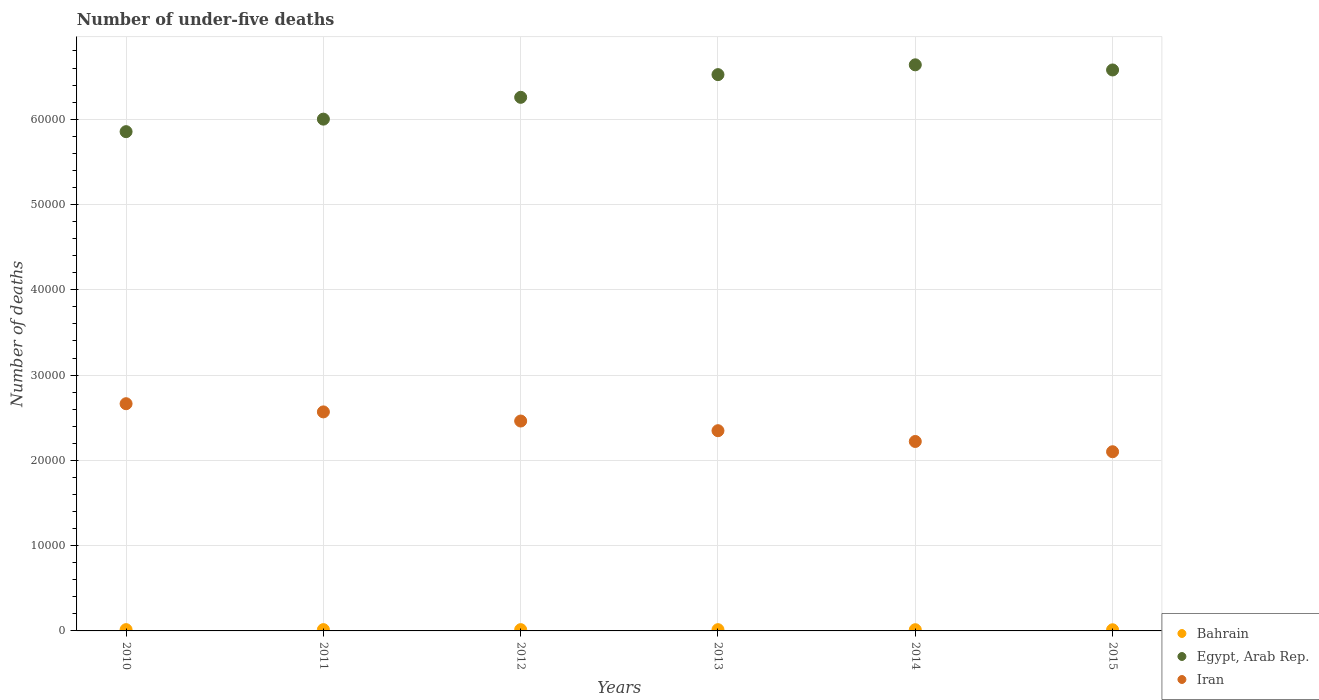How many different coloured dotlines are there?
Your answer should be compact. 3. What is the number of under-five deaths in Egypt, Arab Rep. in 2014?
Your answer should be very brief. 6.64e+04. Across all years, what is the maximum number of under-five deaths in Iran?
Keep it short and to the point. 2.66e+04. Across all years, what is the minimum number of under-five deaths in Bahrain?
Provide a short and direct response. 135. In which year was the number of under-five deaths in Bahrain maximum?
Your answer should be very brief. 2011. What is the total number of under-five deaths in Bahrain in the graph?
Provide a succinct answer. 878. What is the difference between the number of under-five deaths in Iran in 2010 and that in 2012?
Make the answer very short. 2030. What is the difference between the number of under-five deaths in Bahrain in 2011 and the number of under-five deaths in Egypt, Arab Rep. in 2014?
Make the answer very short. -6.62e+04. What is the average number of under-five deaths in Egypt, Arab Rep. per year?
Offer a very short reply. 6.31e+04. In the year 2014, what is the difference between the number of under-five deaths in Iran and number of under-five deaths in Egypt, Arab Rep.?
Provide a succinct answer. -4.42e+04. What is the ratio of the number of under-five deaths in Egypt, Arab Rep. in 2014 to that in 2015?
Provide a short and direct response. 1.01. Is the number of under-five deaths in Iran in 2010 less than that in 2011?
Provide a succinct answer. No. What is the difference between the highest and the lowest number of under-five deaths in Egypt, Arab Rep.?
Keep it short and to the point. 7837. How many years are there in the graph?
Provide a succinct answer. 6. What is the difference between two consecutive major ticks on the Y-axis?
Ensure brevity in your answer.  10000. Does the graph contain any zero values?
Keep it short and to the point. No. Does the graph contain grids?
Your answer should be compact. Yes. Where does the legend appear in the graph?
Offer a very short reply. Bottom right. How many legend labels are there?
Your response must be concise. 3. How are the legend labels stacked?
Provide a succinct answer. Vertical. What is the title of the graph?
Ensure brevity in your answer.  Number of under-five deaths. What is the label or title of the Y-axis?
Offer a very short reply. Number of deaths. What is the Number of deaths of Bahrain in 2010?
Your answer should be very brief. 151. What is the Number of deaths of Egypt, Arab Rep. in 2010?
Provide a succinct answer. 5.85e+04. What is the Number of deaths of Iran in 2010?
Your response must be concise. 2.66e+04. What is the Number of deaths in Bahrain in 2011?
Your answer should be compact. 152. What is the Number of deaths in Egypt, Arab Rep. in 2011?
Give a very brief answer. 6.00e+04. What is the Number of deaths in Iran in 2011?
Keep it short and to the point. 2.57e+04. What is the Number of deaths of Bahrain in 2012?
Provide a succinct answer. 150. What is the Number of deaths of Egypt, Arab Rep. in 2012?
Your response must be concise. 6.26e+04. What is the Number of deaths of Iran in 2012?
Offer a very short reply. 2.46e+04. What is the Number of deaths in Bahrain in 2013?
Give a very brief answer. 148. What is the Number of deaths of Egypt, Arab Rep. in 2013?
Your response must be concise. 6.52e+04. What is the Number of deaths of Iran in 2013?
Provide a succinct answer. 2.35e+04. What is the Number of deaths in Bahrain in 2014?
Give a very brief answer. 142. What is the Number of deaths of Egypt, Arab Rep. in 2014?
Keep it short and to the point. 6.64e+04. What is the Number of deaths in Iran in 2014?
Keep it short and to the point. 2.22e+04. What is the Number of deaths of Bahrain in 2015?
Keep it short and to the point. 135. What is the Number of deaths in Egypt, Arab Rep. in 2015?
Give a very brief answer. 6.58e+04. What is the Number of deaths in Iran in 2015?
Keep it short and to the point. 2.10e+04. Across all years, what is the maximum Number of deaths in Bahrain?
Make the answer very short. 152. Across all years, what is the maximum Number of deaths in Egypt, Arab Rep.?
Your answer should be very brief. 6.64e+04. Across all years, what is the maximum Number of deaths in Iran?
Your response must be concise. 2.66e+04. Across all years, what is the minimum Number of deaths in Bahrain?
Offer a terse response. 135. Across all years, what is the minimum Number of deaths of Egypt, Arab Rep.?
Make the answer very short. 5.85e+04. Across all years, what is the minimum Number of deaths in Iran?
Make the answer very short. 2.10e+04. What is the total Number of deaths of Bahrain in the graph?
Provide a short and direct response. 878. What is the total Number of deaths of Egypt, Arab Rep. in the graph?
Provide a succinct answer. 3.78e+05. What is the total Number of deaths in Iran in the graph?
Your response must be concise. 1.44e+05. What is the difference between the Number of deaths of Egypt, Arab Rep. in 2010 and that in 2011?
Provide a succinct answer. -1468. What is the difference between the Number of deaths in Iran in 2010 and that in 2011?
Provide a succinct answer. 960. What is the difference between the Number of deaths in Bahrain in 2010 and that in 2012?
Offer a terse response. 1. What is the difference between the Number of deaths in Egypt, Arab Rep. in 2010 and that in 2012?
Give a very brief answer. -4026. What is the difference between the Number of deaths of Iran in 2010 and that in 2012?
Keep it short and to the point. 2030. What is the difference between the Number of deaths in Egypt, Arab Rep. in 2010 and that in 2013?
Provide a succinct answer. -6687. What is the difference between the Number of deaths in Iran in 2010 and that in 2013?
Make the answer very short. 3164. What is the difference between the Number of deaths of Egypt, Arab Rep. in 2010 and that in 2014?
Provide a short and direct response. -7837. What is the difference between the Number of deaths in Iran in 2010 and that in 2014?
Your answer should be very brief. 4427. What is the difference between the Number of deaths in Egypt, Arab Rep. in 2010 and that in 2015?
Your answer should be compact. -7234. What is the difference between the Number of deaths of Iran in 2010 and that in 2015?
Give a very brief answer. 5631. What is the difference between the Number of deaths in Bahrain in 2011 and that in 2012?
Offer a terse response. 2. What is the difference between the Number of deaths in Egypt, Arab Rep. in 2011 and that in 2012?
Give a very brief answer. -2558. What is the difference between the Number of deaths in Iran in 2011 and that in 2012?
Your answer should be compact. 1070. What is the difference between the Number of deaths of Egypt, Arab Rep. in 2011 and that in 2013?
Your answer should be very brief. -5219. What is the difference between the Number of deaths of Iran in 2011 and that in 2013?
Make the answer very short. 2204. What is the difference between the Number of deaths in Bahrain in 2011 and that in 2014?
Ensure brevity in your answer.  10. What is the difference between the Number of deaths in Egypt, Arab Rep. in 2011 and that in 2014?
Your response must be concise. -6369. What is the difference between the Number of deaths of Iran in 2011 and that in 2014?
Your answer should be very brief. 3467. What is the difference between the Number of deaths of Bahrain in 2011 and that in 2015?
Offer a very short reply. 17. What is the difference between the Number of deaths in Egypt, Arab Rep. in 2011 and that in 2015?
Your answer should be compact. -5766. What is the difference between the Number of deaths in Iran in 2011 and that in 2015?
Offer a very short reply. 4671. What is the difference between the Number of deaths of Egypt, Arab Rep. in 2012 and that in 2013?
Provide a succinct answer. -2661. What is the difference between the Number of deaths of Iran in 2012 and that in 2013?
Your response must be concise. 1134. What is the difference between the Number of deaths in Egypt, Arab Rep. in 2012 and that in 2014?
Ensure brevity in your answer.  -3811. What is the difference between the Number of deaths in Iran in 2012 and that in 2014?
Make the answer very short. 2397. What is the difference between the Number of deaths in Bahrain in 2012 and that in 2015?
Provide a short and direct response. 15. What is the difference between the Number of deaths in Egypt, Arab Rep. in 2012 and that in 2015?
Keep it short and to the point. -3208. What is the difference between the Number of deaths of Iran in 2012 and that in 2015?
Keep it short and to the point. 3601. What is the difference between the Number of deaths of Bahrain in 2013 and that in 2014?
Make the answer very short. 6. What is the difference between the Number of deaths in Egypt, Arab Rep. in 2013 and that in 2014?
Provide a short and direct response. -1150. What is the difference between the Number of deaths of Iran in 2013 and that in 2014?
Provide a succinct answer. 1263. What is the difference between the Number of deaths of Bahrain in 2013 and that in 2015?
Keep it short and to the point. 13. What is the difference between the Number of deaths of Egypt, Arab Rep. in 2013 and that in 2015?
Offer a terse response. -547. What is the difference between the Number of deaths in Iran in 2013 and that in 2015?
Provide a short and direct response. 2467. What is the difference between the Number of deaths in Bahrain in 2014 and that in 2015?
Offer a very short reply. 7. What is the difference between the Number of deaths in Egypt, Arab Rep. in 2014 and that in 2015?
Offer a very short reply. 603. What is the difference between the Number of deaths of Iran in 2014 and that in 2015?
Your response must be concise. 1204. What is the difference between the Number of deaths of Bahrain in 2010 and the Number of deaths of Egypt, Arab Rep. in 2011?
Your answer should be compact. -5.99e+04. What is the difference between the Number of deaths in Bahrain in 2010 and the Number of deaths in Iran in 2011?
Offer a terse response. -2.55e+04. What is the difference between the Number of deaths in Egypt, Arab Rep. in 2010 and the Number of deaths in Iran in 2011?
Keep it short and to the point. 3.29e+04. What is the difference between the Number of deaths of Bahrain in 2010 and the Number of deaths of Egypt, Arab Rep. in 2012?
Ensure brevity in your answer.  -6.24e+04. What is the difference between the Number of deaths of Bahrain in 2010 and the Number of deaths of Iran in 2012?
Ensure brevity in your answer.  -2.45e+04. What is the difference between the Number of deaths of Egypt, Arab Rep. in 2010 and the Number of deaths of Iran in 2012?
Ensure brevity in your answer.  3.39e+04. What is the difference between the Number of deaths in Bahrain in 2010 and the Number of deaths in Egypt, Arab Rep. in 2013?
Ensure brevity in your answer.  -6.51e+04. What is the difference between the Number of deaths of Bahrain in 2010 and the Number of deaths of Iran in 2013?
Your response must be concise. -2.33e+04. What is the difference between the Number of deaths in Egypt, Arab Rep. in 2010 and the Number of deaths in Iran in 2013?
Keep it short and to the point. 3.51e+04. What is the difference between the Number of deaths of Bahrain in 2010 and the Number of deaths of Egypt, Arab Rep. in 2014?
Ensure brevity in your answer.  -6.62e+04. What is the difference between the Number of deaths in Bahrain in 2010 and the Number of deaths in Iran in 2014?
Ensure brevity in your answer.  -2.21e+04. What is the difference between the Number of deaths of Egypt, Arab Rep. in 2010 and the Number of deaths of Iran in 2014?
Provide a succinct answer. 3.63e+04. What is the difference between the Number of deaths in Bahrain in 2010 and the Number of deaths in Egypt, Arab Rep. in 2015?
Give a very brief answer. -6.56e+04. What is the difference between the Number of deaths of Bahrain in 2010 and the Number of deaths of Iran in 2015?
Provide a succinct answer. -2.09e+04. What is the difference between the Number of deaths in Egypt, Arab Rep. in 2010 and the Number of deaths in Iran in 2015?
Your answer should be very brief. 3.75e+04. What is the difference between the Number of deaths of Bahrain in 2011 and the Number of deaths of Egypt, Arab Rep. in 2012?
Provide a succinct answer. -6.24e+04. What is the difference between the Number of deaths of Bahrain in 2011 and the Number of deaths of Iran in 2012?
Your answer should be very brief. -2.45e+04. What is the difference between the Number of deaths of Egypt, Arab Rep. in 2011 and the Number of deaths of Iran in 2012?
Keep it short and to the point. 3.54e+04. What is the difference between the Number of deaths of Bahrain in 2011 and the Number of deaths of Egypt, Arab Rep. in 2013?
Provide a short and direct response. -6.51e+04. What is the difference between the Number of deaths of Bahrain in 2011 and the Number of deaths of Iran in 2013?
Give a very brief answer. -2.33e+04. What is the difference between the Number of deaths in Egypt, Arab Rep. in 2011 and the Number of deaths in Iran in 2013?
Offer a terse response. 3.65e+04. What is the difference between the Number of deaths in Bahrain in 2011 and the Number of deaths in Egypt, Arab Rep. in 2014?
Make the answer very short. -6.62e+04. What is the difference between the Number of deaths in Bahrain in 2011 and the Number of deaths in Iran in 2014?
Give a very brief answer. -2.21e+04. What is the difference between the Number of deaths of Egypt, Arab Rep. in 2011 and the Number of deaths of Iran in 2014?
Offer a terse response. 3.78e+04. What is the difference between the Number of deaths of Bahrain in 2011 and the Number of deaths of Egypt, Arab Rep. in 2015?
Provide a succinct answer. -6.56e+04. What is the difference between the Number of deaths in Bahrain in 2011 and the Number of deaths in Iran in 2015?
Keep it short and to the point. -2.09e+04. What is the difference between the Number of deaths in Egypt, Arab Rep. in 2011 and the Number of deaths in Iran in 2015?
Make the answer very short. 3.90e+04. What is the difference between the Number of deaths of Bahrain in 2012 and the Number of deaths of Egypt, Arab Rep. in 2013?
Your response must be concise. -6.51e+04. What is the difference between the Number of deaths of Bahrain in 2012 and the Number of deaths of Iran in 2013?
Provide a short and direct response. -2.33e+04. What is the difference between the Number of deaths of Egypt, Arab Rep. in 2012 and the Number of deaths of Iran in 2013?
Offer a very short reply. 3.91e+04. What is the difference between the Number of deaths of Bahrain in 2012 and the Number of deaths of Egypt, Arab Rep. in 2014?
Provide a short and direct response. -6.62e+04. What is the difference between the Number of deaths in Bahrain in 2012 and the Number of deaths in Iran in 2014?
Provide a succinct answer. -2.21e+04. What is the difference between the Number of deaths in Egypt, Arab Rep. in 2012 and the Number of deaths in Iran in 2014?
Your answer should be compact. 4.04e+04. What is the difference between the Number of deaths in Bahrain in 2012 and the Number of deaths in Egypt, Arab Rep. in 2015?
Offer a terse response. -6.56e+04. What is the difference between the Number of deaths in Bahrain in 2012 and the Number of deaths in Iran in 2015?
Provide a short and direct response. -2.09e+04. What is the difference between the Number of deaths in Egypt, Arab Rep. in 2012 and the Number of deaths in Iran in 2015?
Make the answer very short. 4.16e+04. What is the difference between the Number of deaths of Bahrain in 2013 and the Number of deaths of Egypt, Arab Rep. in 2014?
Provide a succinct answer. -6.62e+04. What is the difference between the Number of deaths in Bahrain in 2013 and the Number of deaths in Iran in 2014?
Provide a succinct answer. -2.21e+04. What is the difference between the Number of deaths in Egypt, Arab Rep. in 2013 and the Number of deaths in Iran in 2014?
Your response must be concise. 4.30e+04. What is the difference between the Number of deaths in Bahrain in 2013 and the Number of deaths in Egypt, Arab Rep. in 2015?
Your answer should be compact. -6.56e+04. What is the difference between the Number of deaths in Bahrain in 2013 and the Number of deaths in Iran in 2015?
Keep it short and to the point. -2.09e+04. What is the difference between the Number of deaths of Egypt, Arab Rep. in 2013 and the Number of deaths of Iran in 2015?
Offer a very short reply. 4.42e+04. What is the difference between the Number of deaths in Bahrain in 2014 and the Number of deaths in Egypt, Arab Rep. in 2015?
Provide a succinct answer. -6.56e+04. What is the difference between the Number of deaths of Bahrain in 2014 and the Number of deaths of Iran in 2015?
Ensure brevity in your answer.  -2.09e+04. What is the difference between the Number of deaths in Egypt, Arab Rep. in 2014 and the Number of deaths in Iran in 2015?
Your answer should be compact. 4.54e+04. What is the average Number of deaths of Bahrain per year?
Your answer should be very brief. 146.33. What is the average Number of deaths of Egypt, Arab Rep. per year?
Keep it short and to the point. 6.31e+04. What is the average Number of deaths in Iran per year?
Your response must be concise. 2.39e+04. In the year 2010, what is the difference between the Number of deaths of Bahrain and Number of deaths of Egypt, Arab Rep.?
Offer a terse response. -5.84e+04. In the year 2010, what is the difference between the Number of deaths of Bahrain and Number of deaths of Iran?
Your answer should be very brief. -2.65e+04. In the year 2010, what is the difference between the Number of deaths in Egypt, Arab Rep. and Number of deaths in Iran?
Your answer should be compact. 3.19e+04. In the year 2011, what is the difference between the Number of deaths in Bahrain and Number of deaths in Egypt, Arab Rep.?
Your response must be concise. -5.99e+04. In the year 2011, what is the difference between the Number of deaths of Bahrain and Number of deaths of Iran?
Offer a very short reply. -2.55e+04. In the year 2011, what is the difference between the Number of deaths in Egypt, Arab Rep. and Number of deaths in Iran?
Keep it short and to the point. 3.43e+04. In the year 2012, what is the difference between the Number of deaths in Bahrain and Number of deaths in Egypt, Arab Rep.?
Provide a short and direct response. -6.24e+04. In the year 2012, what is the difference between the Number of deaths in Bahrain and Number of deaths in Iran?
Keep it short and to the point. -2.45e+04. In the year 2012, what is the difference between the Number of deaths in Egypt, Arab Rep. and Number of deaths in Iran?
Your answer should be very brief. 3.80e+04. In the year 2013, what is the difference between the Number of deaths in Bahrain and Number of deaths in Egypt, Arab Rep.?
Your response must be concise. -6.51e+04. In the year 2013, what is the difference between the Number of deaths in Bahrain and Number of deaths in Iran?
Offer a terse response. -2.33e+04. In the year 2013, what is the difference between the Number of deaths of Egypt, Arab Rep. and Number of deaths of Iran?
Give a very brief answer. 4.18e+04. In the year 2014, what is the difference between the Number of deaths in Bahrain and Number of deaths in Egypt, Arab Rep.?
Your answer should be very brief. -6.62e+04. In the year 2014, what is the difference between the Number of deaths of Bahrain and Number of deaths of Iran?
Make the answer very short. -2.21e+04. In the year 2014, what is the difference between the Number of deaths of Egypt, Arab Rep. and Number of deaths of Iran?
Provide a succinct answer. 4.42e+04. In the year 2015, what is the difference between the Number of deaths of Bahrain and Number of deaths of Egypt, Arab Rep.?
Offer a very short reply. -6.56e+04. In the year 2015, what is the difference between the Number of deaths in Bahrain and Number of deaths in Iran?
Ensure brevity in your answer.  -2.09e+04. In the year 2015, what is the difference between the Number of deaths in Egypt, Arab Rep. and Number of deaths in Iran?
Give a very brief answer. 4.48e+04. What is the ratio of the Number of deaths of Bahrain in 2010 to that in 2011?
Offer a terse response. 0.99. What is the ratio of the Number of deaths of Egypt, Arab Rep. in 2010 to that in 2011?
Provide a short and direct response. 0.98. What is the ratio of the Number of deaths of Iran in 2010 to that in 2011?
Ensure brevity in your answer.  1.04. What is the ratio of the Number of deaths of Bahrain in 2010 to that in 2012?
Give a very brief answer. 1.01. What is the ratio of the Number of deaths in Egypt, Arab Rep. in 2010 to that in 2012?
Make the answer very short. 0.94. What is the ratio of the Number of deaths in Iran in 2010 to that in 2012?
Provide a short and direct response. 1.08. What is the ratio of the Number of deaths in Bahrain in 2010 to that in 2013?
Provide a short and direct response. 1.02. What is the ratio of the Number of deaths in Egypt, Arab Rep. in 2010 to that in 2013?
Your answer should be compact. 0.9. What is the ratio of the Number of deaths in Iran in 2010 to that in 2013?
Offer a terse response. 1.13. What is the ratio of the Number of deaths in Bahrain in 2010 to that in 2014?
Give a very brief answer. 1.06. What is the ratio of the Number of deaths in Egypt, Arab Rep. in 2010 to that in 2014?
Provide a succinct answer. 0.88. What is the ratio of the Number of deaths in Iran in 2010 to that in 2014?
Your answer should be very brief. 1.2. What is the ratio of the Number of deaths of Bahrain in 2010 to that in 2015?
Provide a succinct answer. 1.12. What is the ratio of the Number of deaths of Egypt, Arab Rep. in 2010 to that in 2015?
Ensure brevity in your answer.  0.89. What is the ratio of the Number of deaths of Iran in 2010 to that in 2015?
Provide a short and direct response. 1.27. What is the ratio of the Number of deaths of Bahrain in 2011 to that in 2012?
Offer a terse response. 1.01. What is the ratio of the Number of deaths in Egypt, Arab Rep. in 2011 to that in 2012?
Offer a very short reply. 0.96. What is the ratio of the Number of deaths in Iran in 2011 to that in 2012?
Offer a terse response. 1.04. What is the ratio of the Number of deaths of Bahrain in 2011 to that in 2013?
Ensure brevity in your answer.  1.03. What is the ratio of the Number of deaths of Egypt, Arab Rep. in 2011 to that in 2013?
Keep it short and to the point. 0.92. What is the ratio of the Number of deaths in Iran in 2011 to that in 2013?
Give a very brief answer. 1.09. What is the ratio of the Number of deaths of Bahrain in 2011 to that in 2014?
Offer a very short reply. 1.07. What is the ratio of the Number of deaths of Egypt, Arab Rep. in 2011 to that in 2014?
Your answer should be very brief. 0.9. What is the ratio of the Number of deaths of Iran in 2011 to that in 2014?
Your answer should be very brief. 1.16. What is the ratio of the Number of deaths of Bahrain in 2011 to that in 2015?
Ensure brevity in your answer.  1.13. What is the ratio of the Number of deaths of Egypt, Arab Rep. in 2011 to that in 2015?
Make the answer very short. 0.91. What is the ratio of the Number of deaths of Iran in 2011 to that in 2015?
Provide a succinct answer. 1.22. What is the ratio of the Number of deaths of Bahrain in 2012 to that in 2013?
Offer a very short reply. 1.01. What is the ratio of the Number of deaths in Egypt, Arab Rep. in 2012 to that in 2013?
Your answer should be compact. 0.96. What is the ratio of the Number of deaths in Iran in 2012 to that in 2013?
Your response must be concise. 1.05. What is the ratio of the Number of deaths of Bahrain in 2012 to that in 2014?
Make the answer very short. 1.06. What is the ratio of the Number of deaths in Egypt, Arab Rep. in 2012 to that in 2014?
Keep it short and to the point. 0.94. What is the ratio of the Number of deaths of Iran in 2012 to that in 2014?
Your response must be concise. 1.11. What is the ratio of the Number of deaths of Egypt, Arab Rep. in 2012 to that in 2015?
Make the answer very short. 0.95. What is the ratio of the Number of deaths in Iran in 2012 to that in 2015?
Offer a terse response. 1.17. What is the ratio of the Number of deaths in Bahrain in 2013 to that in 2014?
Your response must be concise. 1.04. What is the ratio of the Number of deaths of Egypt, Arab Rep. in 2013 to that in 2014?
Provide a succinct answer. 0.98. What is the ratio of the Number of deaths in Iran in 2013 to that in 2014?
Provide a succinct answer. 1.06. What is the ratio of the Number of deaths in Bahrain in 2013 to that in 2015?
Give a very brief answer. 1.1. What is the ratio of the Number of deaths in Iran in 2013 to that in 2015?
Offer a terse response. 1.12. What is the ratio of the Number of deaths in Bahrain in 2014 to that in 2015?
Your answer should be compact. 1.05. What is the ratio of the Number of deaths of Egypt, Arab Rep. in 2014 to that in 2015?
Make the answer very short. 1.01. What is the ratio of the Number of deaths of Iran in 2014 to that in 2015?
Give a very brief answer. 1.06. What is the difference between the highest and the second highest Number of deaths of Bahrain?
Ensure brevity in your answer.  1. What is the difference between the highest and the second highest Number of deaths of Egypt, Arab Rep.?
Your answer should be compact. 603. What is the difference between the highest and the second highest Number of deaths in Iran?
Offer a very short reply. 960. What is the difference between the highest and the lowest Number of deaths in Bahrain?
Keep it short and to the point. 17. What is the difference between the highest and the lowest Number of deaths in Egypt, Arab Rep.?
Your answer should be compact. 7837. What is the difference between the highest and the lowest Number of deaths of Iran?
Give a very brief answer. 5631. 